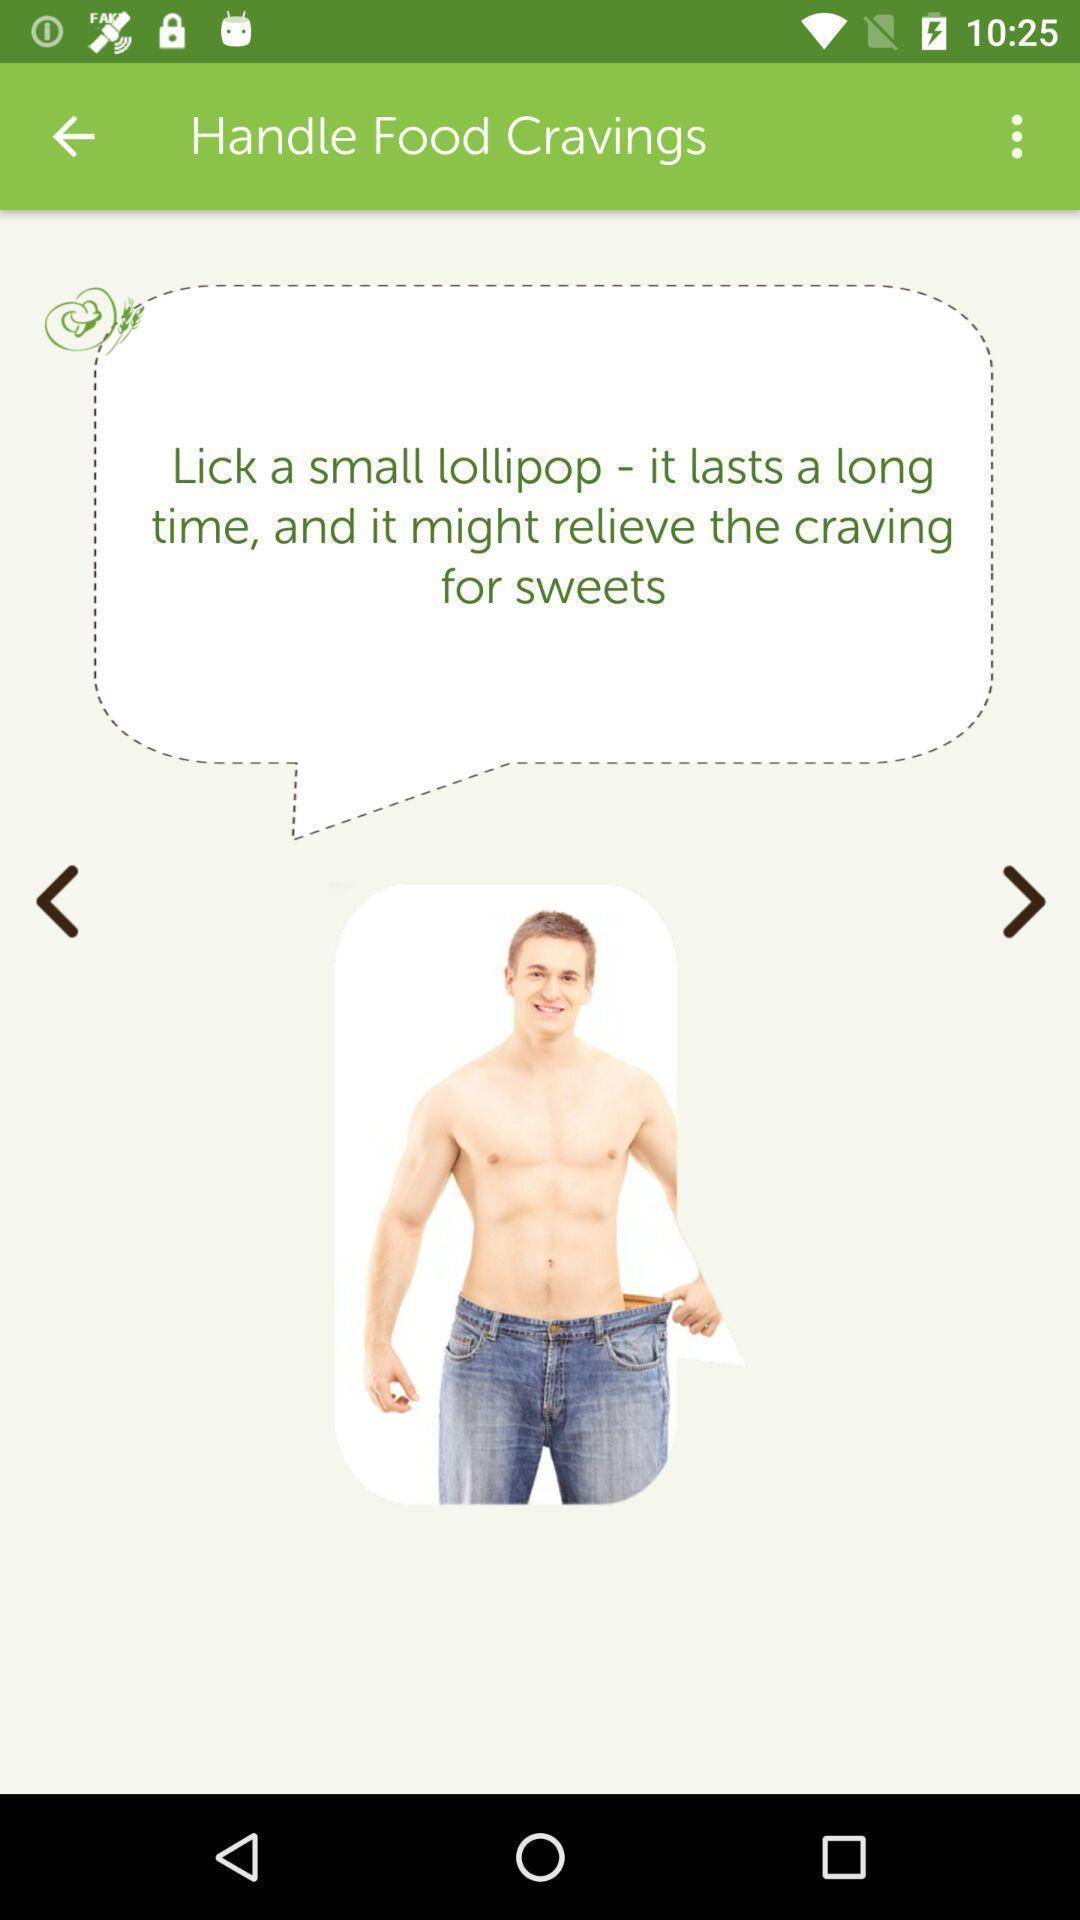Provide a textual representation of this image. Screen shows information about weight tracker. 